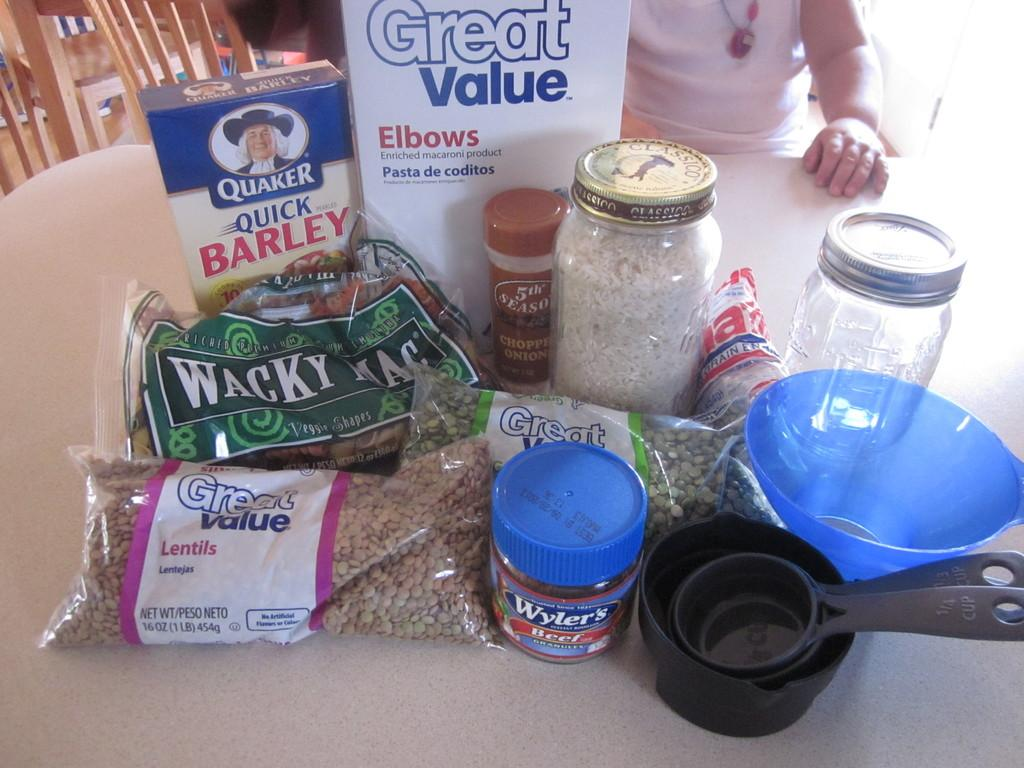<image>
Present a compact description of the photo's key features. A table full of cooking ingredients including Wyler's beef bouillon. 